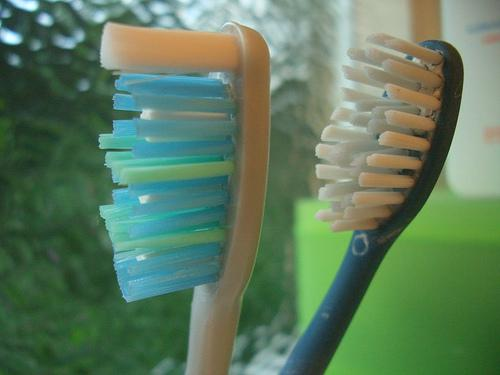Question: what color are the blue toothbrushes' bristles?
Choices:
A. Red.
B. White.
C. Yellow.
D. Cream.
Answer with the letter. Answer: B Question: how many people are there?
Choices:
A. None.
B. Two.
C. Three.
D. Four.
Answer with the letter. Answer: A Question: what room is this?
Choices:
A. Bathroom.
B. Laundry room.
C. Kitchen.
D. Living room.
Answer with the letter. Answer: A Question: what objects are those?
Choices:
A. Toothbrushes.
B. Shampoo.
C. Razors.
D. Floss.
Answer with the letter. Answer: A Question: what color are the bristles of the white brush?
Choices:
A. White.
B. Yellow and white.
C. Red and white.
D. Blue.
Answer with the letter. Answer: D 